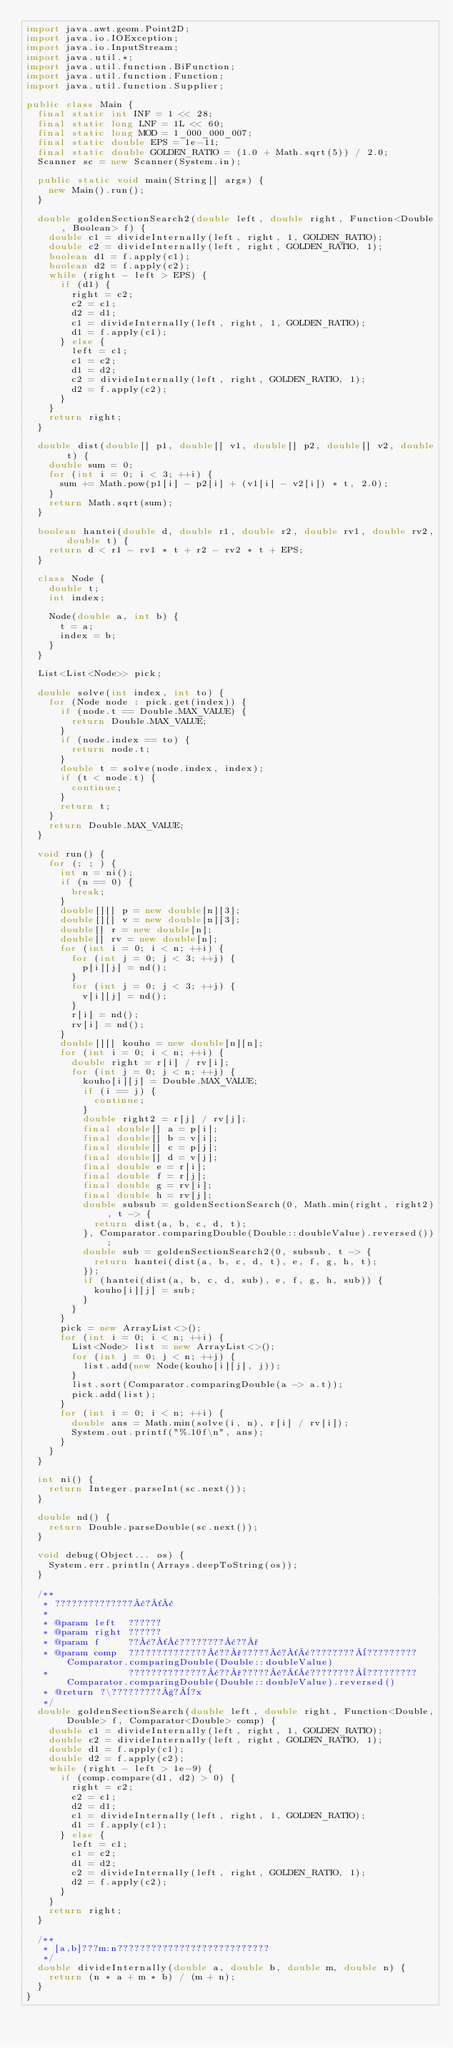Convert code to text. <code><loc_0><loc_0><loc_500><loc_500><_Java_>import java.awt.geom.Point2D;
import java.io.IOException;
import java.io.InputStream;
import java.util.*;
import java.util.function.BiFunction;
import java.util.function.Function;
import java.util.function.Supplier;

public class Main {
  final static int INF = 1 << 28;
  final static long LNF = 1L << 60;
  final static long MOD = 1_000_000_007;
  final static double EPS = 1e-11;
  final static double GOLDEN_RATIO = (1.0 + Math.sqrt(5)) / 2.0;
  Scanner sc = new Scanner(System.in);

  public static void main(String[] args) {
    new Main().run();
  }

  double goldenSectionSearch2(double left, double right, Function<Double, Boolean> f) {
    double c1 = divideInternally(left, right, 1, GOLDEN_RATIO);
    double c2 = divideInternally(left, right, GOLDEN_RATIO, 1);
    boolean d1 = f.apply(c1);
    boolean d2 = f.apply(c2);
    while (right - left > EPS) {
      if (d1) {
        right = c2;
        c2 = c1;
        d2 = d1;
        c1 = divideInternally(left, right, 1, GOLDEN_RATIO);
        d1 = f.apply(c1);
      } else {
        left = c1;
        c1 = c2;
        d1 = d2;
        c2 = divideInternally(left, right, GOLDEN_RATIO, 1);
        d2 = f.apply(c2);
      }
    }
    return right;
  }

  double dist(double[] p1, double[] v1, double[] p2, double[] v2, double t) {
    double sum = 0;
    for (int i = 0; i < 3; ++i) {
      sum += Math.pow(p1[i] - p2[i] + (v1[i] - v2[i]) * t, 2.0);
    }
    return Math.sqrt(sum);
  }

  boolean hantei(double d, double r1, double r2, double rv1, double rv2, double t) {
    return d < r1 - rv1 * t + r2 - rv2 * t + EPS;
  }

  class Node {
    double t;
    int index;

    Node(double a, int b) {
      t = a;
      index = b;
    }
  }

  List<List<Node>> pick;

  double solve(int index, int to) {
    for (Node node : pick.get(index)) {
      if (node.t == Double.MAX_VALUE) {
        return Double.MAX_VALUE;
      }
      if (node.index == to) {
        return node.t;
      }
      double t = solve(node.index, index);
      if (t < node.t) {
        continue;
      }
      return t;
    }
    return Double.MAX_VALUE;
  }

  void run() {
    for (; ; ) {
      int n = ni();
      if (n == 0) {
        break;
      }
      double[][] p = new double[n][3];
      double[][] v = new double[n][3];
      double[] r = new double[n];
      double[] rv = new double[n];
      for (int i = 0; i < n; ++i) {
        for (int j = 0; j < 3; ++j) {
          p[i][j] = nd();
        }
        for (int j = 0; j < 3; ++j) {
          v[i][j] = nd();
        }
        r[i] = nd();
        rv[i] = nd();
      }
      double[][] kouho = new double[n][n];
      for (int i = 0; i < n; ++i) {
        double right = r[i] / rv[i];
        for (int j = 0; j < n; ++j) {
          kouho[i][j] = Double.MAX_VALUE;
          if (i == j) {
            continue;
          }
          double right2 = r[j] / rv[j];
          final double[] a = p[i];
          final double[] b = v[i];
          final double[] c = p[j];
          final double[] d = v[j];
          final double e = r[i];
          final double f = r[j];
          final double g = rv[i];
          final double h = rv[j];
          double subsub = goldenSectionSearch(0, Math.min(right, right2), t -> {
            return dist(a, b, c, d, t);
          }, Comparator.comparingDouble(Double::doubleValue).reversed());
          double sub = goldenSectionSearch2(0, subsub, t -> {
            return hantei(dist(a, b, c, d, t), e, f, g, h, t);
          });
          if (hantei(dist(a, b, c, d, sub), e, f, g, h, sub)) {
            kouho[i][j] = sub;
          }
        }
      }
      pick = new ArrayList<>();
      for (int i = 0; i < n; ++i) {
        List<Node> list = new ArrayList<>();
        for (int j = 0; j < n; ++j) {
          list.add(new Node(kouho[i][j], j));
        }
        list.sort(Comparator.comparingDouble(a -> a.t));
        pick.add(list);
      }
      for (int i = 0; i < n; ++i) {
        double ans = Math.min(solve(i, n), r[i] / rv[i]);
        System.out.printf("%.10f\n", ans);
      }
    }
  }

  int ni() {
    return Integer.parseInt(sc.next());
  }

  double nd() {
    return Double.parseDouble(sc.next());
  }

  void debug(Object... os) {
    System.err.println(Arrays.deepToString(os));
  }

  /**
   * ??????????????¢?´¢
   *
   * @param left  ??????
   * @param right ??????
   * @param f     ??¢?´¢????????¢??°
   * @param comp  ??????????????¢??°?????¢?´¢????????¨?????????Comparator.comparingDouble(Double::doubleValue)
   *              ??????????????¢??°?????¢?´¢????????¨?????????Comparator.comparingDouble(Double::doubleValue).reversed()
   * @return ?\?????????§?¨?x
   */
  double goldenSectionSearch(double left, double right, Function<Double, Double> f, Comparator<Double> comp) {
    double c1 = divideInternally(left, right, 1, GOLDEN_RATIO);
    double c2 = divideInternally(left, right, GOLDEN_RATIO, 1);
    double d1 = f.apply(c1);
    double d2 = f.apply(c2);
    while (right - left > 1e-9) {
      if (comp.compare(d1, d2) > 0) {
        right = c2;
        c2 = c1;
        d2 = d1;
        c1 = divideInternally(left, right, 1, GOLDEN_RATIO);
        d1 = f.apply(c1);
      } else {
        left = c1;
        c1 = c2;
        d1 = d2;
        c2 = divideInternally(left, right, GOLDEN_RATIO, 1);
        d2 = f.apply(c2);
      }
    }
    return right;
  }

  /**
   * [a,b]???m:n???????????????????????????
   */
  double divideInternally(double a, double b, double m, double n) {
    return (n * a + m * b) / (m + n);
  }
}</code> 